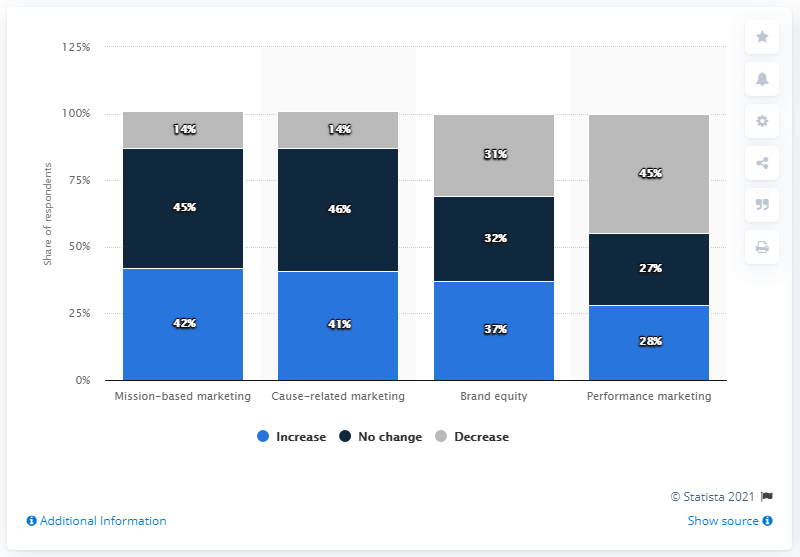Mention a couple of crucial points in this snapshot. The highest increase and decrease percentage is 3. A significant number of advertising professionals in the United States have planned to modify their messaging strategy in response to the ongoing coronavirus outbreak, with a focus on mission-based marketing. 